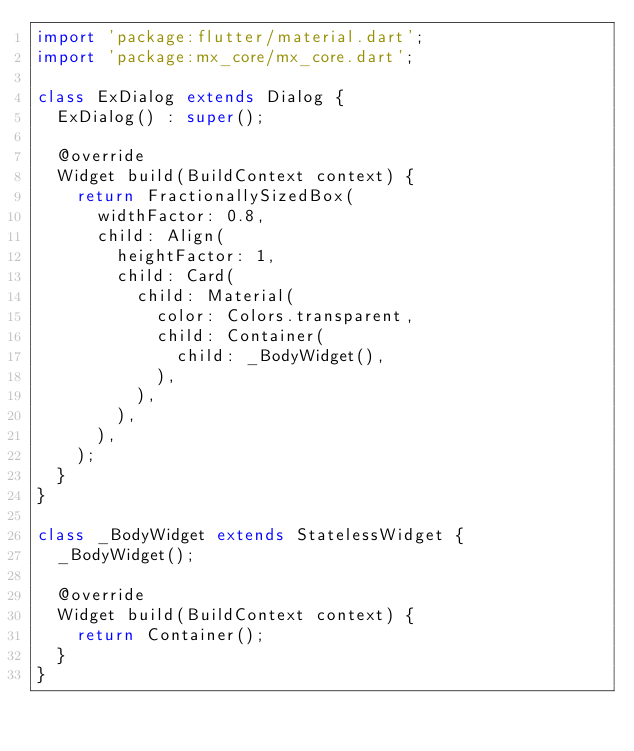Convert code to text. <code><loc_0><loc_0><loc_500><loc_500><_Dart_>import 'package:flutter/material.dart';
import 'package:mx_core/mx_core.dart';

class ExDialog extends Dialog {
  ExDialog() : super();

  @override
  Widget build(BuildContext context) {
    return FractionallySizedBox(
      widthFactor: 0.8,
      child: Align(
        heightFactor: 1,
        child: Card(
          child: Material(
            color: Colors.transparent,
            child: Container(
              child: _BodyWidget(),
            ),
          ),
        ),
      ),
    );
  }
}

class _BodyWidget extends StatelessWidget {
  _BodyWidget();

  @override
  Widget build(BuildContext context) {
    return Container();
  }
}
</code> 